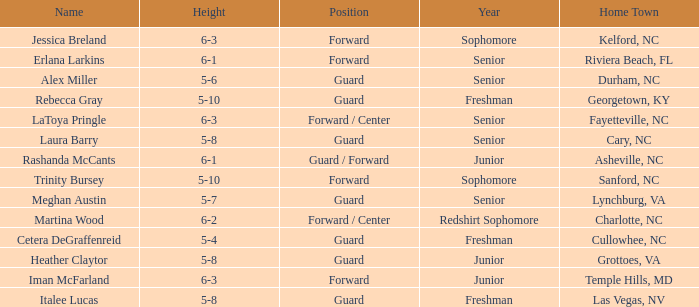What is the name of the guard from Cary, NC? Laura Barry. 